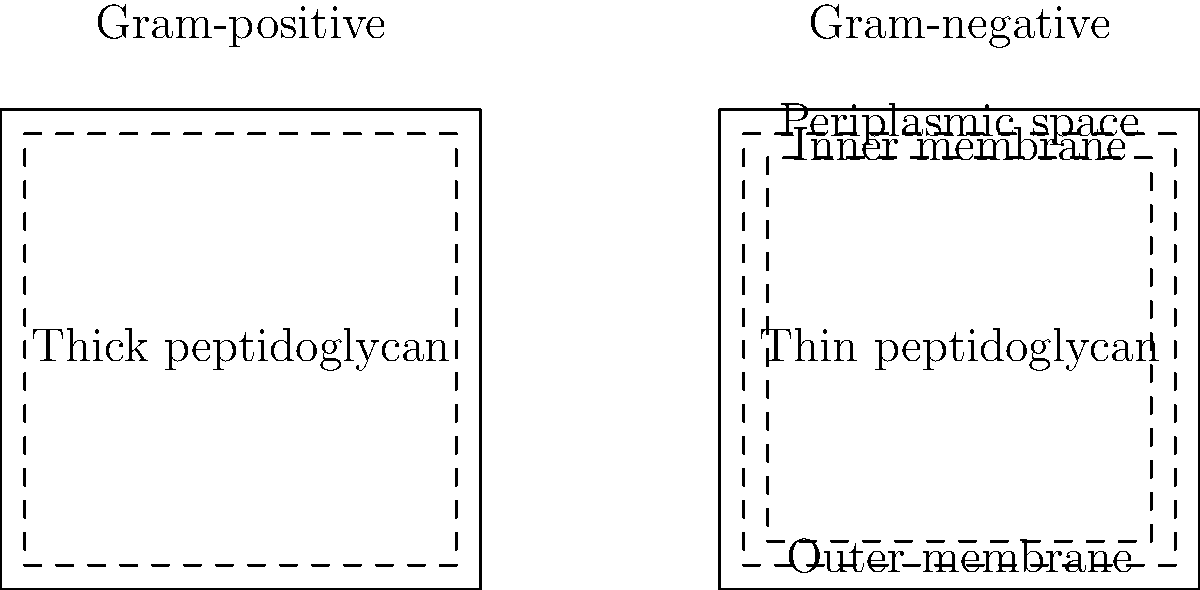Analyze the side-by-side diagrams of Gram-positive and Gram-negative bacterial cell envelopes. What is the key structural difference that allows Gram-negative bacteria to be more resistant to certain antibiotics compared to Gram-positive bacteria? To answer this question, let's analyze the structural differences between Gram-positive and Gram-negative bacterial cell envelopes:

1. Gram-positive bacteria:
   - Have a thick peptidoglycan layer (represented by the wide space between the outer and inner lines)
   - Lack an outer membrane

2. Gram-negative bacteria:
   - Have a thin peptidoglycan layer (represented by the narrow space between the two inner lines)
   - Possess an outer membrane (represented by the outermost line)

3. The key difference in antibiotic resistance:
   - The outer membrane in Gram-negative bacteria acts as an additional barrier
   - This membrane contains lipopolysaccharides (LPS) and porins, which control the entry of molecules
   - Many antibiotics struggle to penetrate this outer membrane

4. Antibiotic resistance mechanism:
   - The outer membrane reduces the permeability of the cell envelope
   - It prevents or slows down the entry of large or hydrophobic antibiotic molecules
   - Some antibiotics that are effective against Gram-positive bacteria cannot reach their targets in Gram-negative bacteria

5. Examples of affected antibiotics:
   - Vancomycin, a large glycopeptide antibiotic, is effective against Gram-positive bacteria but not Gram-negative bacteria due to its inability to penetrate the outer membrane

Therefore, the presence of the outer membrane in Gram-negative bacteria is the key structural difference that contributes to their increased resistance to certain antibiotics compared to Gram-positive bacteria.
Answer: The outer membrane in Gram-negative bacteria 